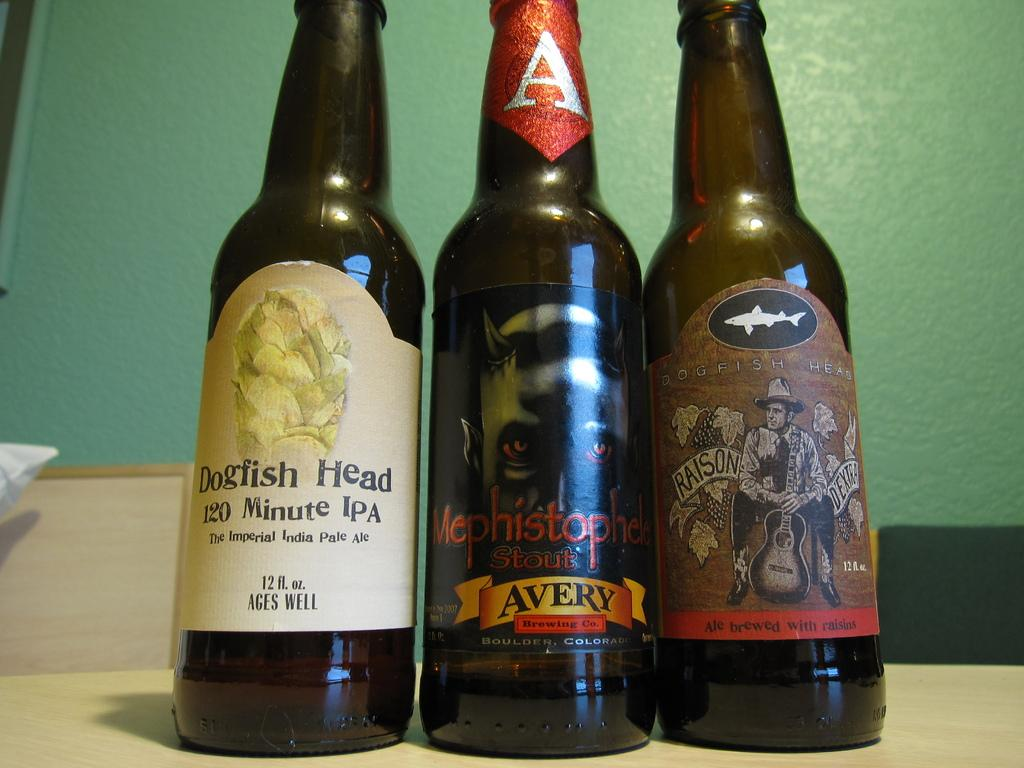<image>
Share a concise interpretation of the image provided. The middle beer comes from Avery Brewing company. 